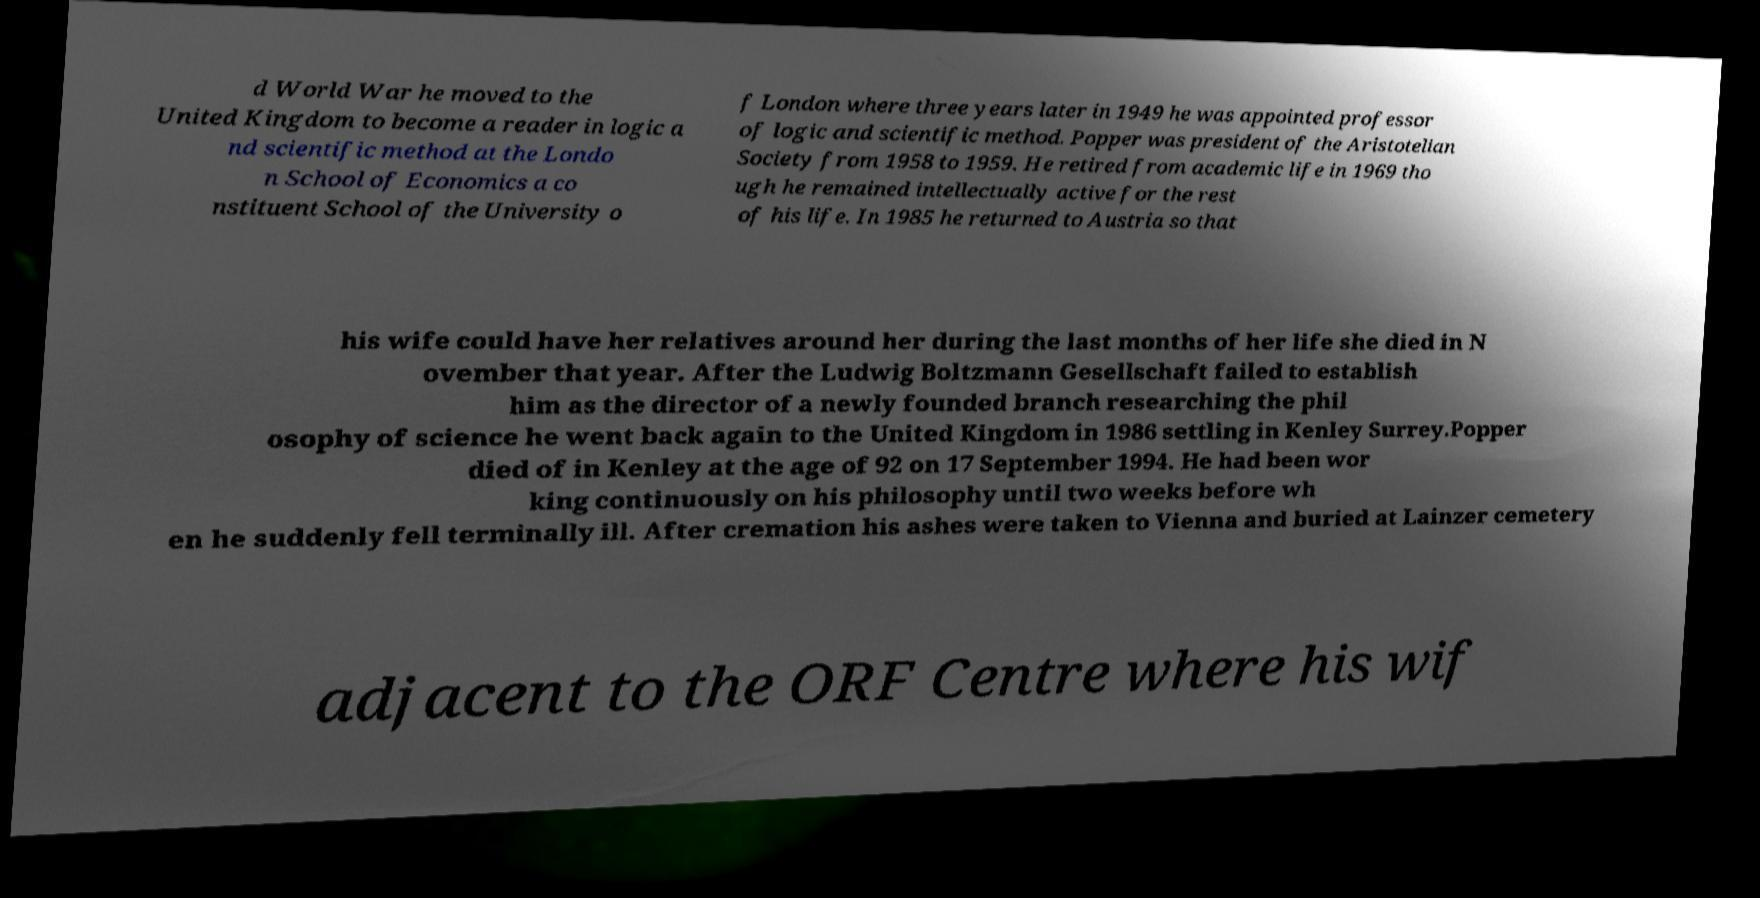What messages or text are displayed in this image? I need them in a readable, typed format. d World War he moved to the United Kingdom to become a reader in logic a nd scientific method at the Londo n School of Economics a co nstituent School of the University o f London where three years later in 1949 he was appointed professor of logic and scientific method. Popper was president of the Aristotelian Society from 1958 to 1959. He retired from academic life in 1969 tho ugh he remained intellectually active for the rest of his life. In 1985 he returned to Austria so that his wife could have her relatives around her during the last months of her life she died in N ovember that year. After the Ludwig Boltzmann Gesellschaft failed to establish him as the director of a newly founded branch researching the phil osophy of science he went back again to the United Kingdom in 1986 settling in Kenley Surrey.Popper died of in Kenley at the age of 92 on 17 September 1994. He had been wor king continuously on his philosophy until two weeks before wh en he suddenly fell terminally ill. After cremation his ashes were taken to Vienna and buried at Lainzer cemetery adjacent to the ORF Centre where his wif 